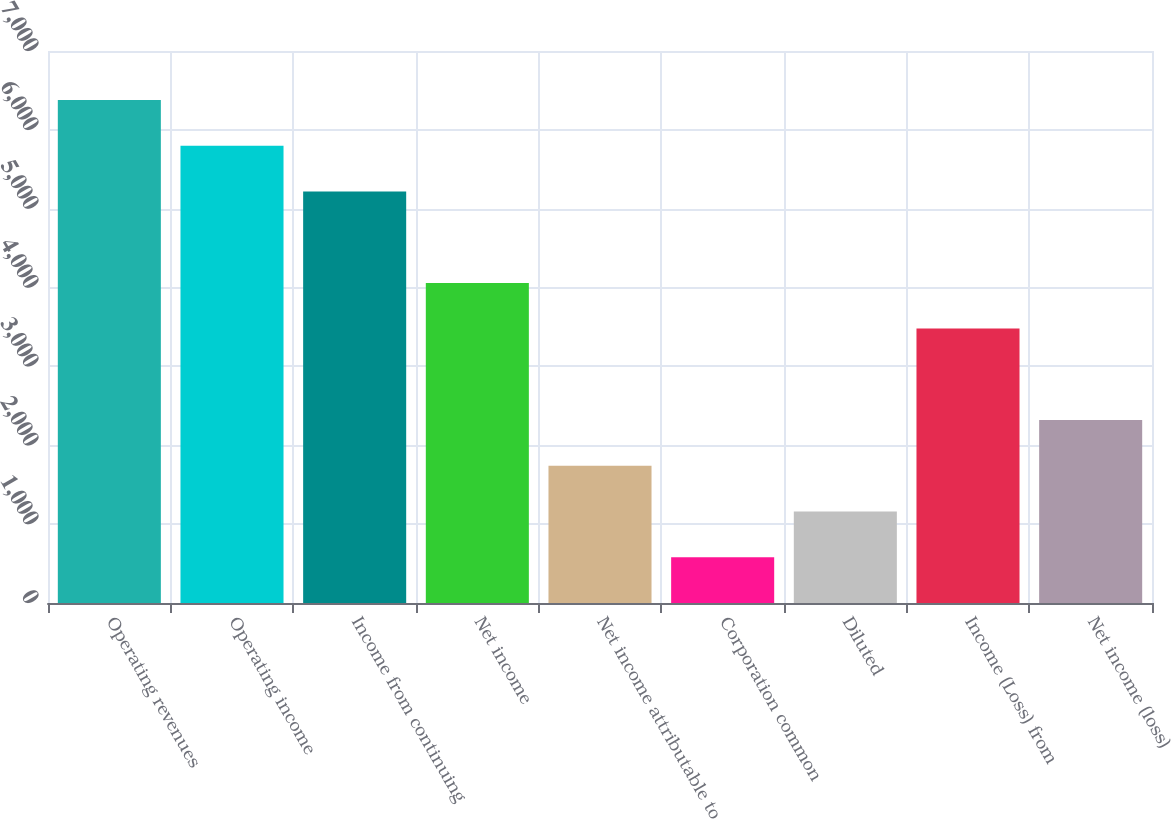<chart> <loc_0><loc_0><loc_500><loc_500><bar_chart><fcel>Operating revenues<fcel>Operating income<fcel>Income from continuing<fcel>Net income<fcel>Net income attributable to<fcel>Corporation common<fcel>Diluted<fcel>Income (Loss) from<fcel>Net income (loss)<nl><fcel>6378.77<fcel>5798.96<fcel>5219.15<fcel>4059.53<fcel>1740.29<fcel>580.67<fcel>1160.48<fcel>3479.72<fcel>2320.1<nl></chart> 